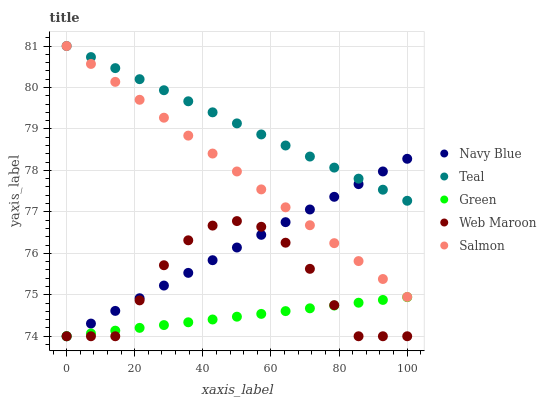Does Green have the minimum area under the curve?
Answer yes or no. Yes. Does Teal have the maximum area under the curve?
Answer yes or no. Yes. Does Navy Blue have the minimum area under the curve?
Answer yes or no. No. Does Navy Blue have the maximum area under the curve?
Answer yes or no. No. Is Green the smoothest?
Answer yes or no. Yes. Is Web Maroon the roughest?
Answer yes or no. Yes. Is Navy Blue the smoothest?
Answer yes or no. No. Is Navy Blue the roughest?
Answer yes or no. No. Does Web Maroon have the lowest value?
Answer yes or no. Yes. Does Teal have the lowest value?
Answer yes or no. No. Does Salmon have the highest value?
Answer yes or no. Yes. Does Navy Blue have the highest value?
Answer yes or no. No. Is Green less than Teal?
Answer yes or no. Yes. Is Salmon greater than Green?
Answer yes or no. Yes. Does Navy Blue intersect Green?
Answer yes or no. Yes. Is Navy Blue less than Green?
Answer yes or no. No. Is Navy Blue greater than Green?
Answer yes or no. No. Does Green intersect Teal?
Answer yes or no. No. 